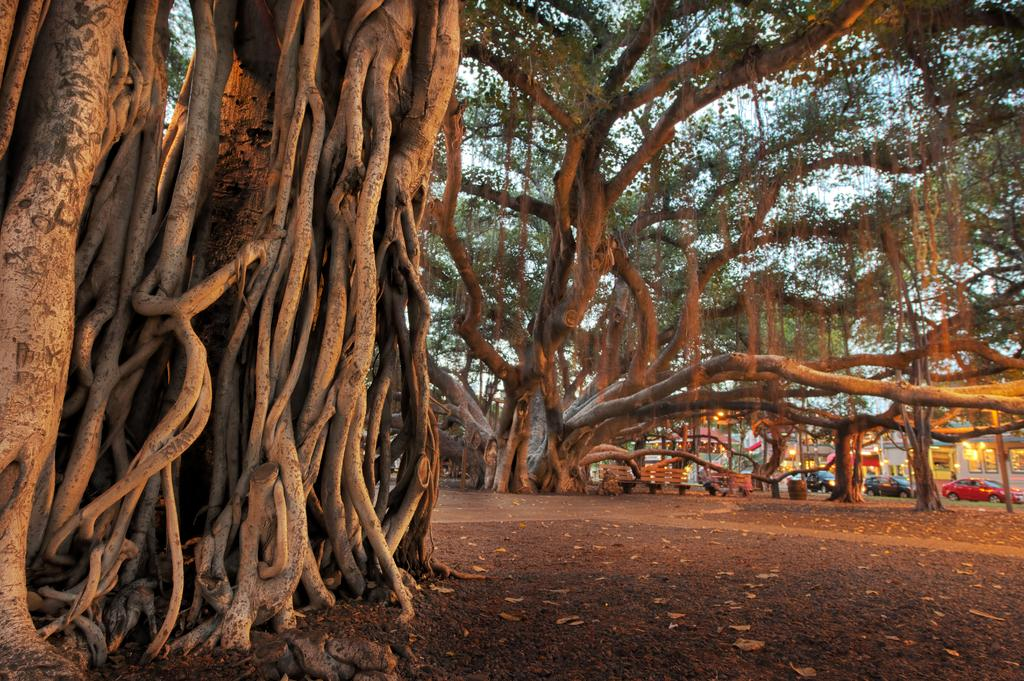What type of vegetation can be seen in the image? There are trees in the image. What type of seating is available in the image? There are benches in the image. What type of transportation can be seen on the road in the image? There are cars on the road in the image. What type of structures are visible in the image? There are buildings in the image. Can you hear the thunder in the image? There is no sound present in the image, so it is not possible to hear thunder. What type of tools does the carpenter use in the image? There is no carpenter present in the image. 